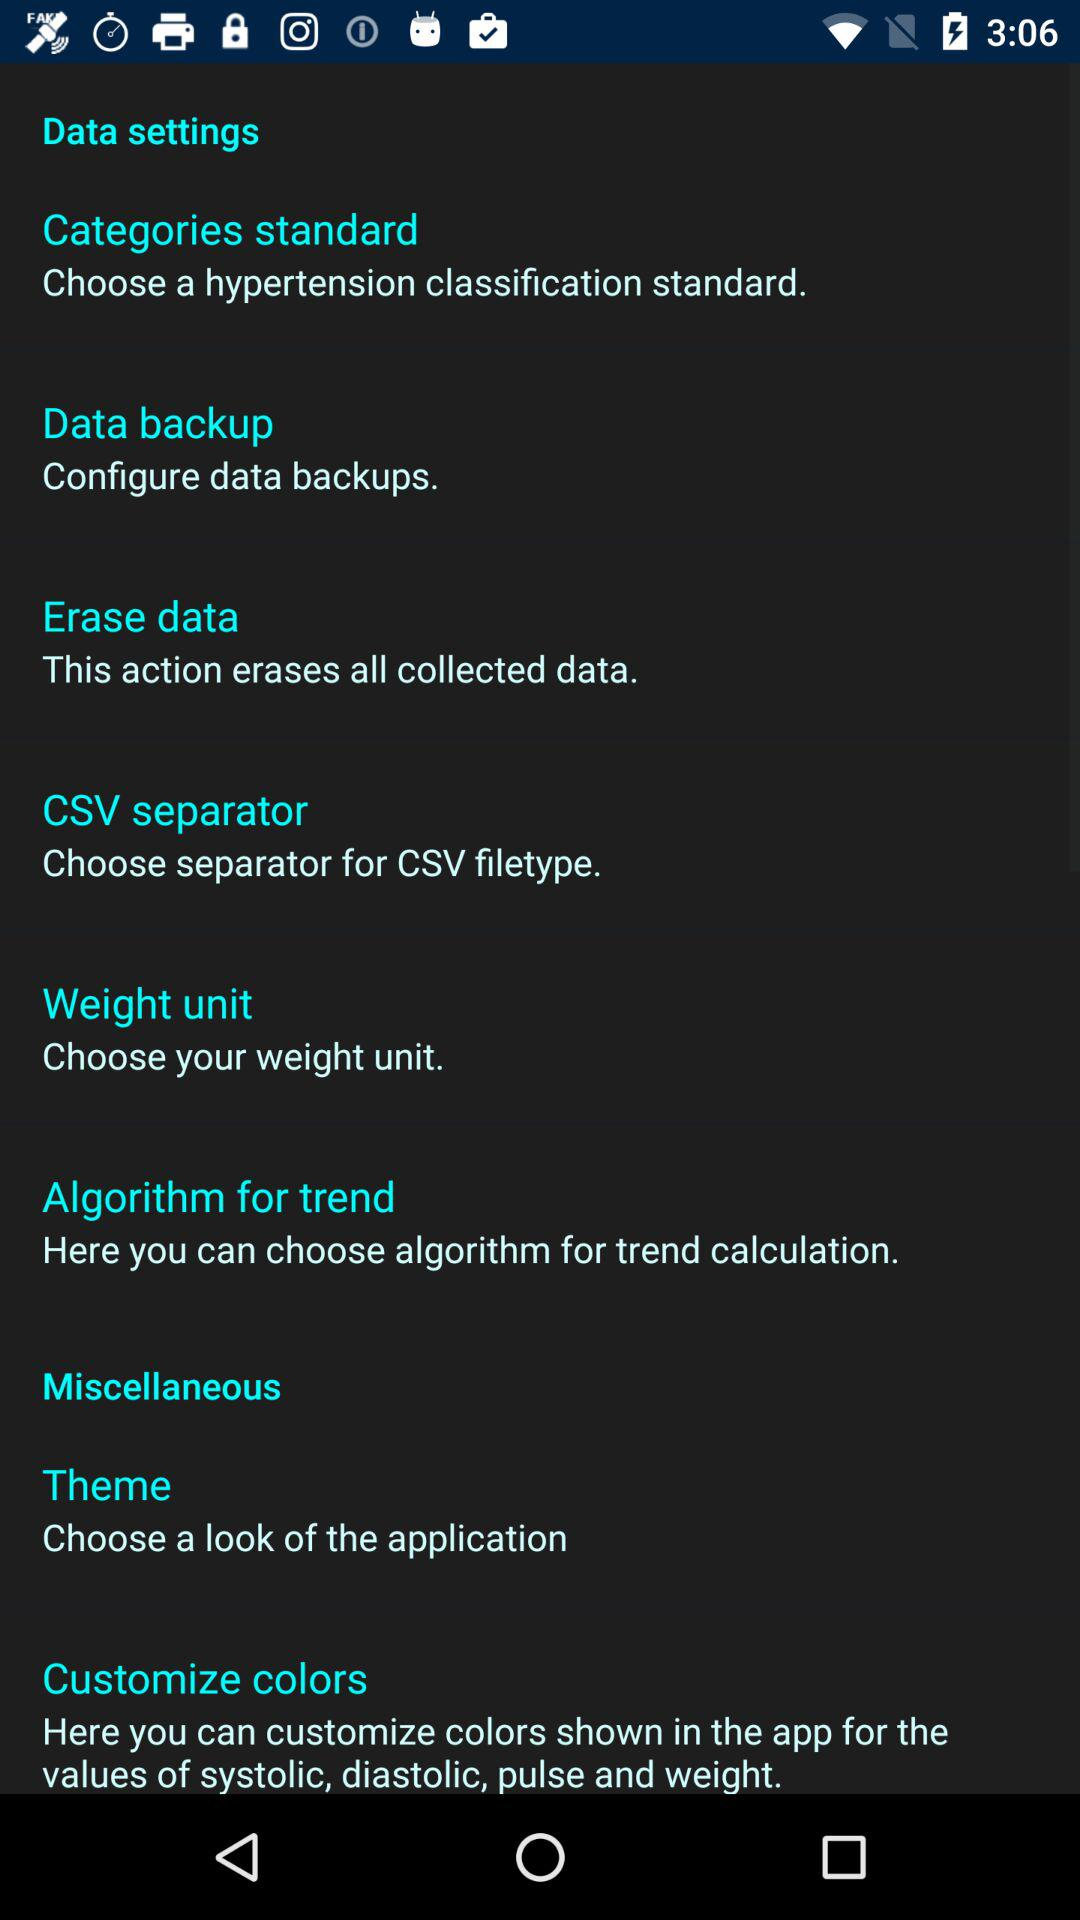Which option is selected?
When the provided information is insufficient, respond with <no answer>. <no answer> 